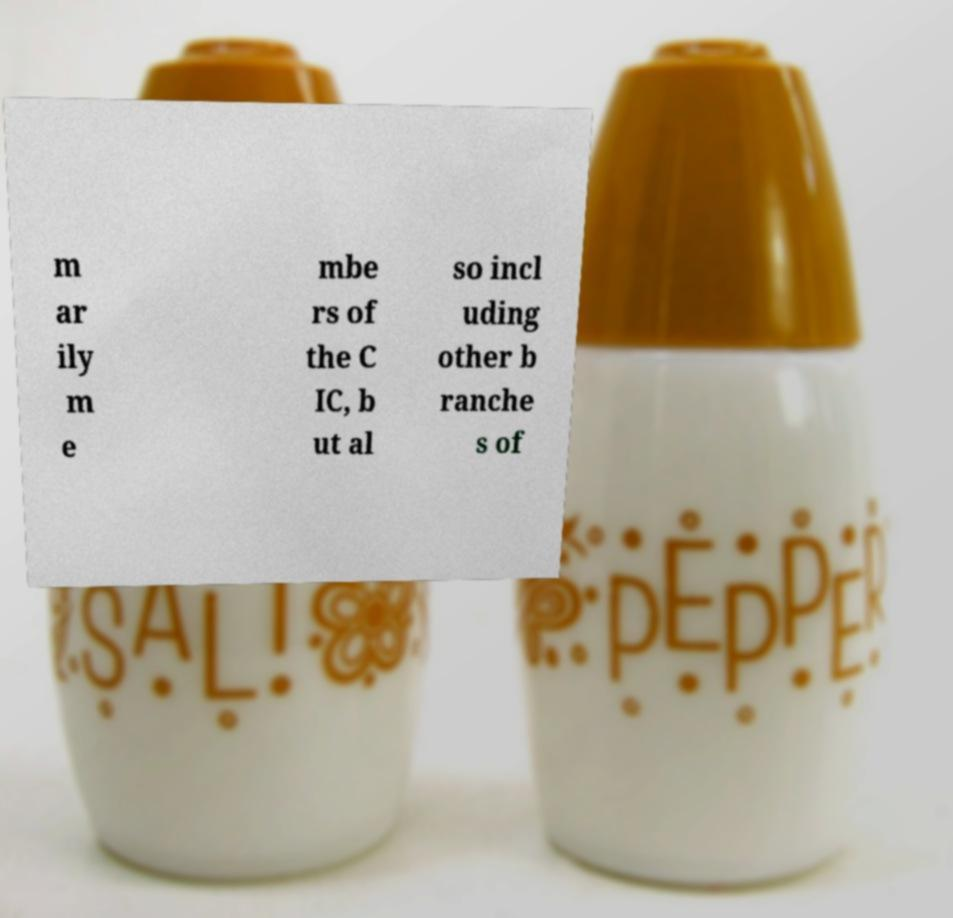There's text embedded in this image that I need extracted. Can you transcribe it verbatim? m ar ily m e mbe rs of the C IC, b ut al so incl uding other b ranche s of 